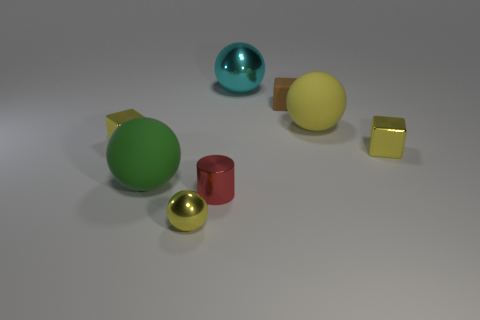Add 2 yellow spheres. How many objects exist? 10 Subtract all cylinders. How many objects are left? 7 Subtract all yellow metallic blocks. Subtract all tiny yellow objects. How many objects are left? 3 Add 1 tiny spheres. How many tiny spheres are left? 2 Add 2 small yellow blocks. How many small yellow blocks exist? 4 Subtract 1 green spheres. How many objects are left? 7 